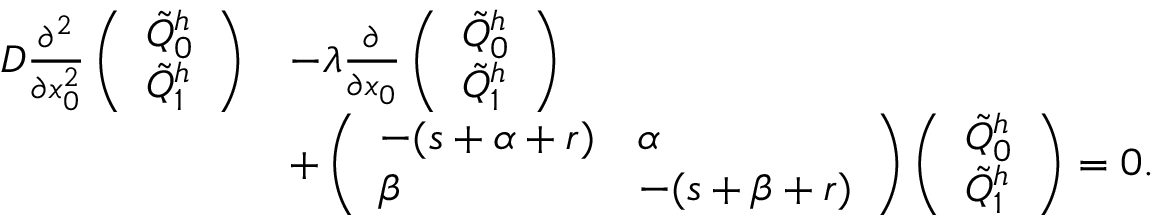Convert formula to latex. <formula><loc_0><loc_0><loc_500><loc_500>\begin{array} { r l } { D \frac { \partial ^ { 2 } } { \partial x _ { 0 } ^ { 2 } } \left ( \begin{array} { l } { \tilde { Q } _ { 0 } ^ { h } } \\ { \tilde { Q } _ { 1 } ^ { h } } \end{array} \right ) } & { - \lambda \frac { \partial } { \partial x _ { 0 } } \left ( \begin{array} { l } { \tilde { Q } _ { 0 } ^ { h } } \\ { \tilde { Q } _ { 1 } ^ { h } } \end{array} \right ) } \\ & { + \left ( \begin{array} { l l } { - ( s + \alpha + r ) } & { \alpha } \\ { \beta } & { - ( s + \beta + r ) } \end{array} \right ) \left ( \begin{array} { l } { \tilde { Q } _ { 0 } ^ { h } } \\ { \tilde { Q } _ { 1 } ^ { h } } \end{array} \right ) = 0 . } \end{array}</formula> 